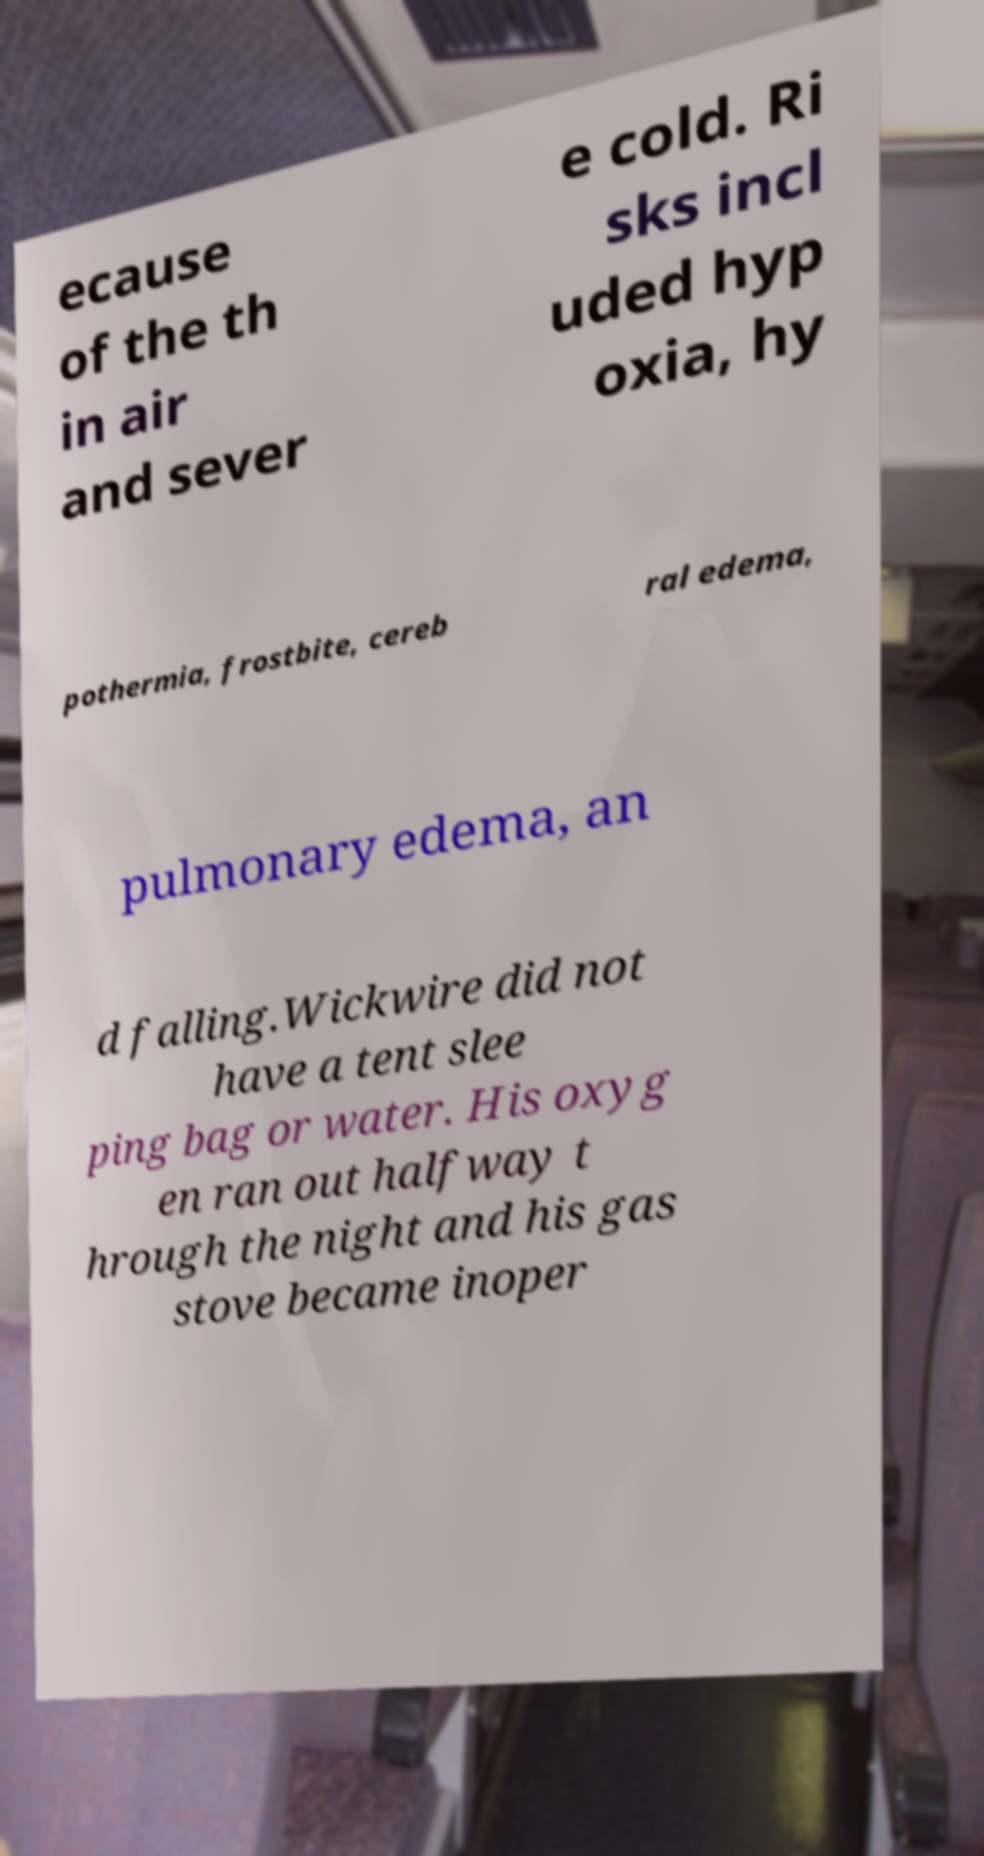I need the written content from this picture converted into text. Can you do that? ecause of the th in air and sever e cold. Ri sks incl uded hyp oxia, hy pothermia, frostbite, cereb ral edema, pulmonary edema, an d falling.Wickwire did not have a tent slee ping bag or water. His oxyg en ran out halfway t hrough the night and his gas stove became inoper 